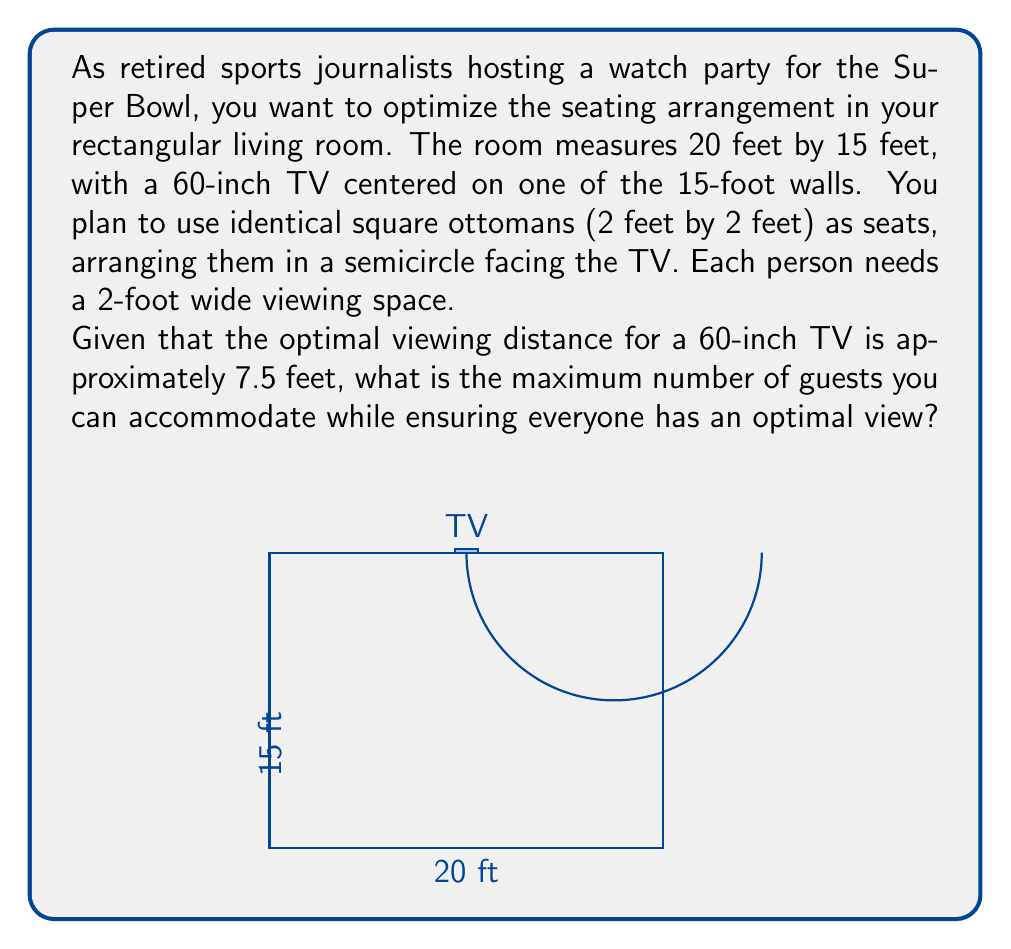Provide a solution to this math problem. Let's approach this step-by-step:

1) First, we need to calculate the radius of the semicircle where the ottomans will be placed:
   - The optimal viewing distance is 7.5 feet from the TV.
   - The room is 15 feet deep, so the semicircle's center will be at the midpoint of the 15-foot wall.
   - Therefore, the radius of the semicircle is 7.5 feet.

2) Now, we need to calculate the circumference of the semicircle:
   $$C = \pi r = \pi \cdot 7.5 \approx 23.56\text{ feet}$$

3) Since we're using a semicircle, we divide this by 2:
   $$\text{Semicircle length} = 23.56 / 2 \approx 11.78\text{ feet}$$

4) Each person needs a 2-foot wide viewing space. To find the number of people we can accommodate, we divide the semicircle length by 2:
   $$\text{Number of people} = 11.78 / 2 \approx 5.89$$

5) Since we can't have a fractional person, we round down to 5.

6) To verify, let's check if 5 ottomans (2 feet each) fit within the 20-foot width of the room:
   $$5 \cdot 2 = 10\text{ feet}$$
   This leaves 5 feet on each side, which is sufficient space.

Therefore, the maximum number of guests you can accommodate while ensuring everyone has an optimal view is 5.
Answer: 5 guests 